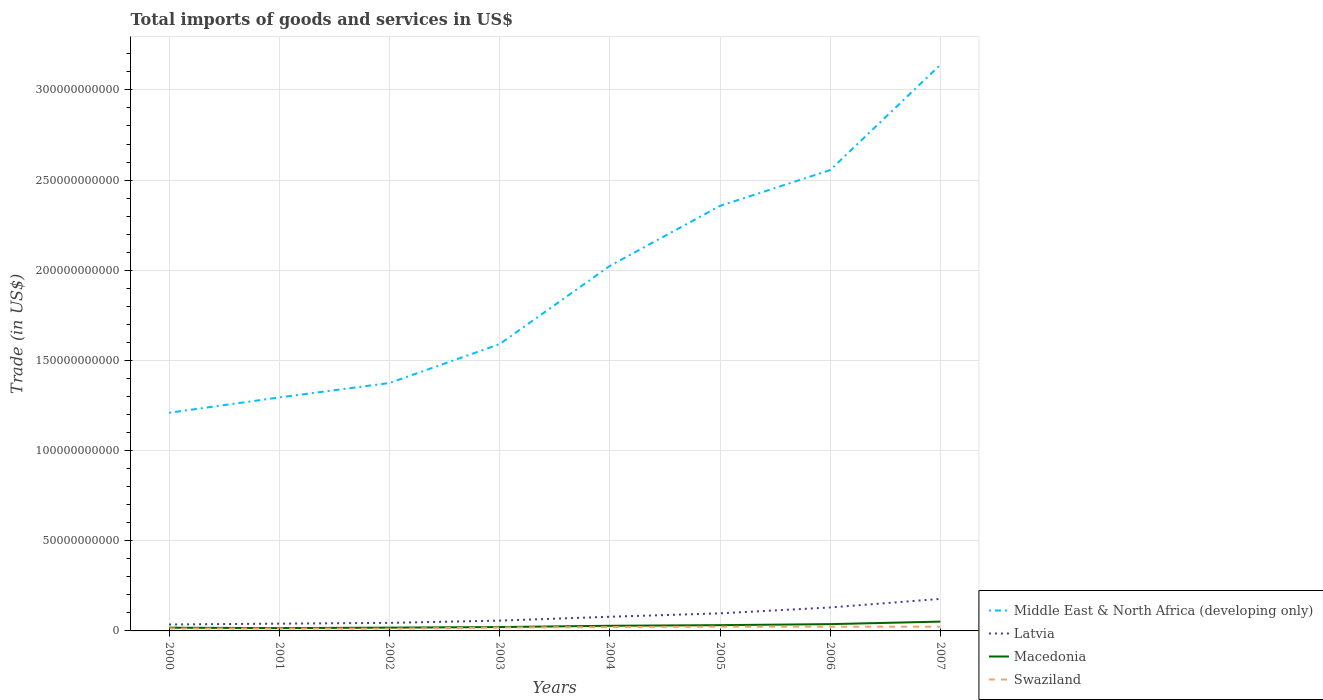How many different coloured lines are there?
Ensure brevity in your answer.  4. Is the number of lines equal to the number of legend labels?
Your response must be concise. Yes. Across all years, what is the maximum total imports of goods and services in Middle East & North Africa (developing only)?
Your response must be concise. 1.21e+11. What is the total total imports of goods and services in Macedonia in the graph?
Your answer should be very brief. -1.38e+09. What is the difference between the highest and the second highest total imports of goods and services in Latvia?
Make the answer very short. 1.42e+1. Are the values on the major ticks of Y-axis written in scientific E-notation?
Give a very brief answer. No. How many legend labels are there?
Your answer should be compact. 4. What is the title of the graph?
Your response must be concise. Total imports of goods and services in US$. What is the label or title of the Y-axis?
Provide a succinct answer. Trade (in US$). What is the Trade (in US$) of Middle East & North Africa (developing only) in 2000?
Provide a short and direct response. 1.21e+11. What is the Trade (in US$) in Latvia in 2000?
Offer a very short reply. 3.56e+09. What is the Trade (in US$) of Macedonia in 2000?
Offer a very short reply. 1.78e+09. What is the Trade (in US$) in Swaziland in 2000?
Make the answer very short. 1.34e+09. What is the Trade (in US$) in Middle East & North Africa (developing only) in 2001?
Provide a succinct answer. 1.29e+11. What is the Trade (in US$) in Latvia in 2001?
Make the answer very short. 4.04e+09. What is the Trade (in US$) of Macedonia in 2001?
Keep it short and to the point. 1.57e+09. What is the Trade (in US$) in Swaziland in 2001?
Your answer should be compact. 1.33e+09. What is the Trade (in US$) of Middle East & North Africa (developing only) in 2002?
Your response must be concise. 1.37e+11. What is the Trade (in US$) in Latvia in 2002?
Your response must be concise. 4.46e+09. What is the Trade (in US$) of Macedonia in 2002?
Give a very brief answer. 1.82e+09. What is the Trade (in US$) of Swaziland in 2002?
Provide a short and direct response. 1.24e+09. What is the Trade (in US$) of Middle East & North Africa (developing only) in 2003?
Ensure brevity in your answer.  1.59e+11. What is the Trade (in US$) in Latvia in 2003?
Offer a terse response. 5.72e+09. What is the Trade (in US$) of Macedonia in 2003?
Ensure brevity in your answer.  2.15e+09. What is the Trade (in US$) in Swaziland in 2003?
Offer a terse response. 1.89e+09. What is the Trade (in US$) of Middle East & North Africa (developing only) in 2004?
Provide a short and direct response. 2.02e+11. What is the Trade (in US$) in Latvia in 2004?
Your answer should be compact. 7.85e+09. What is the Trade (in US$) of Macedonia in 2004?
Keep it short and to the point. 2.85e+09. What is the Trade (in US$) in Swaziland in 2004?
Offer a terse response. 2.12e+09. What is the Trade (in US$) of Middle East & North Africa (developing only) in 2005?
Ensure brevity in your answer.  2.36e+11. What is the Trade (in US$) in Latvia in 2005?
Provide a short and direct response. 9.76e+09. What is the Trade (in US$) in Macedonia in 2005?
Offer a very short reply. 3.19e+09. What is the Trade (in US$) of Swaziland in 2005?
Provide a succinct answer. 2.36e+09. What is the Trade (in US$) in Middle East & North Africa (developing only) in 2006?
Offer a very short reply. 2.56e+11. What is the Trade (in US$) of Latvia in 2006?
Provide a succinct answer. 1.30e+1. What is the Trade (in US$) in Macedonia in 2006?
Provide a succinct answer. 3.76e+09. What is the Trade (in US$) of Swaziland in 2006?
Your response must be concise. 2.33e+09. What is the Trade (in US$) in Middle East & North Africa (developing only) in 2007?
Make the answer very short. 3.14e+11. What is the Trade (in US$) in Latvia in 2007?
Your answer should be compact. 1.78e+1. What is the Trade (in US$) in Macedonia in 2007?
Make the answer very short. 5.17e+09. What is the Trade (in US$) in Swaziland in 2007?
Your answer should be very brief. 2.35e+09. Across all years, what is the maximum Trade (in US$) in Middle East & North Africa (developing only)?
Make the answer very short. 3.14e+11. Across all years, what is the maximum Trade (in US$) of Latvia?
Make the answer very short. 1.78e+1. Across all years, what is the maximum Trade (in US$) in Macedonia?
Offer a very short reply. 5.17e+09. Across all years, what is the maximum Trade (in US$) of Swaziland?
Give a very brief answer. 2.36e+09. Across all years, what is the minimum Trade (in US$) of Middle East & North Africa (developing only)?
Keep it short and to the point. 1.21e+11. Across all years, what is the minimum Trade (in US$) in Latvia?
Provide a succinct answer. 3.56e+09. Across all years, what is the minimum Trade (in US$) of Macedonia?
Ensure brevity in your answer.  1.57e+09. Across all years, what is the minimum Trade (in US$) of Swaziland?
Give a very brief answer. 1.24e+09. What is the total Trade (in US$) in Middle East & North Africa (developing only) in the graph?
Your answer should be very brief. 1.55e+12. What is the total Trade (in US$) in Latvia in the graph?
Give a very brief answer. 6.62e+1. What is the total Trade (in US$) of Macedonia in the graph?
Offer a terse response. 2.23e+1. What is the total Trade (in US$) in Swaziland in the graph?
Give a very brief answer. 1.49e+1. What is the difference between the Trade (in US$) in Middle East & North Africa (developing only) in 2000 and that in 2001?
Offer a very short reply. -8.51e+09. What is the difference between the Trade (in US$) of Latvia in 2000 and that in 2001?
Your answer should be very brief. -4.83e+08. What is the difference between the Trade (in US$) of Macedonia in 2000 and that in 2001?
Give a very brief answer. 2.13e+08. What is the difference between the Trade (in US$) in Swaziland in 2000 and that in 2001?
Your answer should be compact. 1.30e+07. What is the difference between the Trade (in US$) in Middle East & North Africa (developing only) in 2000 and that in 2002?
Provide a succinct answer. -1.65e+1. What is the difference between the Trade (in US$) of Latvia in 2000 and that in 2002?
Ensure brevity in your answer.  -8.98e+08. What is the difference between the Trade (in US$) of Macedonia in 2000 and that in 2002?
Your answer should be very brief. -3.63e+07. What is the difference between the Trade (in US$) of Swaziland in 2000 and that in 2002?
Your response must be concise. 1.05e+08. What is the difference between the Trade (in US$) of Middle East & North Africa (developing only) in 2000 and that in 2003?
Provide a succinct answer. -3.81e+1. What is the difference between the Trade (in US$) in Latvia in 2000 and that in 2003?
Your answer should be compact. -2.16e+09. What is the difference between the Trade (in US$) of Macedonia in 2000 and that in 2003?
Provide a succinct answer. -3.66e+08. What is the difference between the Trade (in US$) in Swaziland in 2000 and that in 2003?
Make the answer very short. -5.47e+08. What is the difference between the Trade (in US$) in Middle East & North Africa (developing only) in 2000 and that in 2004?
Make the answer very short. -8.14e+1. What is the difference between the Trade (in US$) of Latvia in 2000 and that in 2004?
Your response must be concise. -4.29e+09. What is the difference between the Trade (in US$) in Macedonia in 2000 and that in 2004?
Make the answer very short. -1.07e+09. What is the difference between the Trade (in US$) of Swaziland in 2000 and that in 2004?
Keep it short and to the point. -7.76e+08. What is the difference between the Trade (in US$) of Middle East & North Africa (developing only) in 2000 and that in 2005?
Offer a terse response. -1.15e+11. What is the difference between the Trade (in US$) of Latvia in 2000 and that in 2005?
Keep it short and to the point. -6.20e+09. What is the difference between the Trade (in US$) of Macedonia in 2000 and that in 2005?
Offer a very short reply. -1.41e+09. What is the difference between the Trade (in US$) of Swaziland in 2000 and that in 2005?
Keep it short and to the point. -1.01e+09. What is the difference between the Trade (in US$) of Middle East & North Africa (developing only) in 2000 and that in 2006?
Keep it short and to the point. -1.35e+11. What is the difference between the Trade (in US$) in Latvia in 2000 and that in 2006?
Ensure brevity in your answer.  -9.44e+09. What is the difference between the Trade (in US$) of Macedonia in 2000 and that in 2006?
Your response must be concise. -1.98e+09. What is the difference between the Trade (in US$) of Swaziland in 2000 and that in 2006?
Make the answer very short. -9.87e+08. What is the difference between the Trade (in US$) in Middle East & North Africa (developing only) in 2000 and that in 2007?
Ensure brevity in your answer.  -1.93e+11. What is the difference between the Trade (in US$) of Latvia in 2000 and that in 2007?
Keep it short and to the point. -1.42e+1. What is the difference between the Trade (in US$) of Macedonia in 2000 and that in 2007?
Offer a terse response. -3.39e+09. What is the difference between the Trade (in US$) in Swaziland in 2000 and that in 2007?
Provide a succinct answer. -1.01e+09. What is the difference between the Trade (in US$) of Middle East & North Africa (developing only) in 2001 and that in 2002?
Make the answer very short. -7.99e+09. What is the difference between the Trade (in US$) of Latvia in 2001 and that in 2002?
Offer a very short reply. -4.15e+08. What is the difference between the Trade (in US$) of Macedonia in 2001 and that in 2002?
Your answer should be compact. -2.49e+08. What is the difference between the Trade (in US$) of Swaziland in 2001 and that in 2002?
Your answer should be compact. 9.20e+07. What is the difference between the Trade (in US$) in Middle East & North Africa (developing only) in 2001 and that in 2003?
Your answer should be compact. -2.96e+1. What is the difference between the Trade (in US$) in Latvia in 2001 and that in 2003?
Your answer should be compact. -1.67e+09. What is the difference between the Trade (in US$) in Macedonia in 2001 and that in 2003?
Offer a terse response. -5.79e+08. What is the difference between the Trade (in US$) in Swaziland in 2001 and that in 2003?
Make the answer very short. -5.60e+08. What is the difference between the Trade (in US$) of Middle East & North Africa (developing only) in 2001 and that in 2004?
Ensure brevity in your answer.  -7.29e+1. What is the difference between the Trade (in US$) of Latvia in 2001 and that in 2004?
Keep it short and to the point. -3.81e+09. What is the difference between the Trade (in US$) of Macedonia in 2001 and that in 2004?
Make the answer very short. -1.28e+09. What is the difference between the Trade (in US$) of Swaziland in 2001 and that in 2004?
Give a very brief answer. -7.89e+08. What is the difference between the Trade (in US$) in Middle East & North Africa (developing only) in 2001 and that in 2005?
Provide a short and direct response. -1.06e+11. What is the difference between the Trade (in US$) in Latvia in 2001 and that in 2005?
Give a very brief answer. -5.71e+09. What is the difference between the Trade (in US$) of Macedonia in 2001 and that in 2005?
Offer a terse response. -1.63e+09. What is the difference between the Trade (in US$) of Swaziland in 2001 and that in 2005?
Provide a succinct answer. -1.03e+09. What is the difference between the Trade (in US$) of Middle East & North Africa (developing only) in 2001 and that in 2006?
Keep it short and to the point. -1.26e+11. What is the difference between the Trade (in US$) in Latvia in 2001 and that in 2006?
Provide a succinct answer. -8.96e+09. What is the difference between the Trade (in US$) of Macedonia in 2001 and that in 2006?
Keep it short and to the point. -2.19e+09. What is the difference between the Trade (in US$) of Swaziland in 2001 and that in 2006?
Offer a very short reply. -1.00e+09. What is the difference between the Trade (in US$) of Middle East & North Africa (developing only) in 2001 and that in 2007?
Give a very brief answer. -1.84e+11. What is the difference between the Trade (in US$) of Latvia in 2001 and that in 2007?
Give a very brief answer. -1.37e+1. What is the difference between the Trade (in US$) of Macedonia in 2001 and that in 2007?
Ensure brevity in your answer.  -3.60e+09. What is the difference between the Trade (in US$) in Swaziland in 2001 and that in 2007?
Provide a short and direct response. -1.02e+09. What is the difference between the Trade (in US$) in Middle East & North Africa (developing only) in 2002 and that in 2003?
Keep it short and to the point. -2.16e+1. What is the difference between the Trade (in US$) of Latvia in 2002 and that in 2003?
Your answer should be compact. -1.26e+09. What is the difference between the Trade (in US$) of Macedonia in 2002 and that in 2003?
Offer a very short reply. -3.30e+08. What is the difference between the Trade (in US$) of Swaziland in 2002 and that in 2003?
Your answer should be very brief. -6.52e+08. What is the difference between the Trade (in US$) in Middle East & North Africa (developing only) in 2002 and that in 2004?
Your answer should be very brief. -6.49e+1. What is the difference between the Trade (in US$) in Latvia in 2002 and that in 2004?
Provide a short and direct response. -3.39e+09. What is the difference between the Trade (in US$) in Macedonia in 2002 and that in 2004?
Provide a short and direct response. -1.03e+09. What is the difference between the Trade (in US$) of Swaziland in 2002 and that in 2004?
Make the answer very short. -8.80e+08. What is the difference between the Trade (in US$) in Middle East & North Africa (developing only) in 2002 and that in 2005?
Keep it short and to the point. -9.82e+1. What is the difference between the Trade (in US$) of Latvia in 2002 and that in 2005?
Give a very brief answer. -5.30e+09. What is the difference between the Trade (in US$) in Macedonia in 2002 and that in 2005?
Your response must be concise. -1.38e+09. What is the difference between the Trade (in US$) of Swaziland in 2002 and that in 2005?
Ensure brevity in your answer.  -1.12e+09. What is the difference between the Trade (in US$) in Middle East & North Africa (developing only) in 2002 and that in 2006?
Give a very brief answer. -1.18e+11. What is the difference between the Trade (in US$) of Latvia in 2002 and that in 2006?
Provide a succinct answer. -8.55e+09. What is the difference between the Trade (in US$) in Macedonia in 2002 and that in 2006?
Keep it short and to the point. -1.94e+09. What is the difference between the Trade (in US$) in Swaziland in 2002 and that in 2006?
Your answer should be compact. -1.09e+09. What is the difference between the Trade (in US$) in Middle East & North Africa (developing only) in 2002 and that in 2007?
Provide a succinct answer. -1.76e+11. What is the difference between the Trade (in US$) of Latvia in 2002 and that in 2007?
Offer a terse response. -1.33e+1. What is the difference between the Trade (in US$) of Macedonia in 2002 and that in 2007?
Your response must be concise. -3.35e+09. What is the difference between the Trade (in US$) in Swaziland in 2002 and that in 2007?
Your response must be concise. -1.11e+09. What is the difference between the Trade (in US$) of Middle East & North Africa (developing only) in 2003 and that in 2004?
Offer a terse response. -4.34e+1. What is the difference between the Trade (in US$) in Latvia in 2003 and that in 2004?
Your response must be concise. -2.14e+09. What is the difference between the Trade (in US$) in Macedonia in 2003 and that in 2004?
Keep it short and to the point. -7.03e+08. What is the difference between the Trade (in US$) in Swaziland in 2003 and that in 2004?
Give a very brief answer. -2.28e+08. What is the difference between the Trade (in US$) in Middle East & North Africa (developing only) in 2003 and that in 2005?
Make the answer very short. -7.66e+1. What is the difference between the Trade (in US$) of Latvia in 2003 and that in 2005?
Your answer should be very brief. -4.04e+09. What is the difference between the Trade (in US$) of Macedonia in 2003 and that in 2005?
Provide a succinct answer. -1.05e+09. What is the difference between the Trade (in US$) of Swaziland in 2003 and that in 2005?
Your response must be concise. -4.67e+08. What is the difference between the Trade (in US$) of Middle East & North Africa (developing only) in 2003 and that in 2006?
Offer a very short reply. -9.65e+1. What is the difference between the Trade (in US$) of Latvia in 2003 and that in 2006?
Provide a short and direct response. -7.29e+09. What is the difference between the Trade (in US$) in Macedonia in 2003 and that in 2006?
Your answer should be very brief. -1.61e+09. What is the difference between the Trade (in US$) in Swaziland in 2003 and that in 2006?
Make the answer very short. -4.40e+08. What is the difference between the Trade (in US$) of Middle East & North Africa (developing only) in 2003 and that in 2007?
Your response must be concise. -1.55e+11. What is the difference between the Trade (in US$) in Latvia in 2003 and that in 2007?
Your answer should be very brief. -1.20e+1. What is the difference between the Trade (in US$) of Macedonia in 2003 and that in 2007?
Make the answer very short. -3.02e+09. What is the difference between the Trade (in US$) of Swaziland in 2003 and that in 2007?
Provide a succinct answer. -4.61e+08. What is the difference between the Trade (in US$) in Middle East & North Africa (developing only) in 2004 and that in 2005?
Provide a short and direct response. -3.33e+1. What is the difference between the Trade (in US$) in Latvia in 2004 and that in 2005?
Make the answer very short. -1.90e+09. What is the difference between the Trade (in US$) of Macedonia in 2004 and that in 2005?
Keep it short and to the point. -3.43e+08. What is the difference between the Trade (in US$) in Swaziland in 2004 and that in 2005?
Make the answer very short. -2.39e+08. What is the difference between the Trade (in US$) of Middle East & North Africa (developing only) in 2004 and that in 2006?
Your answer should be very brief. -5.31e+1. What is the difference between the Trade (in US$) in Latvia in 2004 and that in 2006?
Keep it short and to the point. -5.15e+09. What is the difference between the Trade (in US$) of Macedonia in 2004 and that in 2006?
Your answer should be very brief. -9.06e+08. What is the difference between the Trade (in US$) of Swaziland in 2004 and that in 2006?
Ensure brevity in your answer.  -2.12e+08. What is the difference between the Trade (in US$) of Middle East & North Africa (developing only) in 2004 and that in 2007?
Give a very brief answer. -1.12e+11. What is the difference between the Trade (in US$) of Latvia in 2004 and that in 2007?
Provide a short and direct response. -9.91e+09. What is the difference between the Trade (in US$) in Macedonia in 2004 and that in 2007?
Provide a short and direct response. -2.32e+09. What is the difference between the Trade (in US$) in Swaziland in 2004 and that in 2007?
Your response must be concise. -2.33e+08. What is the difference between the Trade (in US$) of Middle East & North Africa (developing only) in 2005 and that in 2006?
Keep it short and to the point. -1.99e+1. What is the difference between the Trade (in US$) in Latvia in 2005 and that in 2006?
Your answer should be compact. -3.25e+09. What is the difference between the Trade (in US$) in Macedonia in 2005 and that in 2006?
Your answer should be compact. -5.63e+08. What is the difference between the Trade (in US$) of Swaziland in 2005 and that in 2006?
Your answer should be very brief. 2.73e+07. What is the difference between the Trade (in US$) of Middle East & North Africa (developing only) in 2005 and that in 2007?
Your response must be concise. -7.83e+1. What is the difference between the Trade (in US$) of Latvia in 2005 and that in 2007?
Offer a very short reply. -8.00e+09. What is the difference between the Trade (in US$) of Macedonia in 2005 and that in 2007?
Make the answer very short. -1.97e+09. What is the difference between the Trade (in US$) in Swaziland in 2005 and that in 2007?
Offer a very short reply. 6.24e+06. What is the difference between the Trade (in US$) of Middle East & North Africa (developing only) in 2006 and that in 2007?
Give a very brief answer. -5.84e+1. What is the difference between the Trade (in US$) in Latvia in 2006 and that in 2007?
Your response must be concise. -4.75e+09. What is the difference between the Trade (in US$) of Macedonia in 2006 and that in 2007?
Your answer should be very brief. -1.41e+09. What is the difference between the Trade (in US$) of Swaziland in 2006 and that in 2007?
Offer a very short reply. -2.11e+07. What is the difference between the Trade (in US$) of Middle East & North Africa (developing only) in 2000 and the Trade (in US$) of Latvia in 2001?
Ensure brevity in your answer.  1.17e+11. What is the difference between the Trade (in US$) in Middle East & North Africa (developing only) in 2000 and the Trade (in US$) in Macedonia in 2001?
Your response must be concise. 1.19e+11. What is the difference between the Trade (in US$) in Middle East & North Africa (developing only) in 2000 and the Trade (in US$) in Swaziland in 2001?
Provide a short and direct response. 1.20e+11. What is the difference between the Trade (in US$) of Latvia in 2000 and the Trade (in US$) of Macedonia in 2001?
Provide a succinct answer. 1.99e+09. What is the difference between the Trade (in US$) of Latvia in 2000 and the Trade (in US$) of Swaziland in 2001?
Keep it short and to the point. 2.23e+09. What is the difference between the Trade (in US$) in Macedonia in 2000 and the Trade (in US$) in Swaziland in 2001?
Offer a very short reply. 4.52e+08. What is the difference between the Trade (in US$) of Middle East & North Africa (developing only) in 2000 and the Trade (in US$) of Latvia in 2002?
Give a very brief answer. 1.17e+11. What is the difference between the Trade (in US$) in Middle East & North Africa (developing only) in 2000 and the Trade (in US$) in Macedonia in 2002?
Offer a terse response. 1.19e+11. What is the difference between the Trade (in US$) of Middle East & North Africa (developing only) in 2000 and the Trade (in US$) of Swaziland in 2002?
Your response must be concise. 1.20e+11. What is the difference between the Trade (in US$) in Latvia in 2000 and the Trade (in US$) in Macedonia in 2002?
Keep it short and to the point. 1.74e+09. What is the difference between the Trade (in US$) in Latvia in 2000 and the Trade (in US$) in Swaziland in 2002?
Ensure brevity in your answer.  2.32e+09. What is the difference between the Trade (in US$) of Macedonia in 2000 and the Trade (in US$) of Swaziland in 2002?
Provide a short and direct response. 5.44e+08. What is the difference between the Trade (in US$) in Middle East & North Africa (developing only) in 2000 and the Trade (in US$) in Latvia in 2003?
Your answer should be compact. 1.15e+11. What is the difference between the Trade (in US$) in Middle East & North Africa (developing only) in 2000 and the Trade (in US$) in Macedonia in 2003?
Keep it short and to the point. 1.19e+11. What is the difference between the Trade (in US$) of Middle East & North Africa (developing only) in 2000 and the Trade (in US$) of Swaziland in 2003?
Offer a terse response. 1.19e+11. What is the difference between the Trade (in US$) in Latvia in 2000 and the Trade (in US$) in Macedonia in 2003?
Offer a terse response. 1.41e+09. What is the difference between the Trade (in US$) of Latvia in 2000 and the Trade (in US$) of Swaziland in 2003?
Your answer should be very brief. 1.67e+09. What is the difference between the Trade (in US$) in Macedonia in 2000 and the Trade (in US$) in Swaziland in 2003?
Make the answer very short. -1.08e+08. What is the difference between the Trade (in US$) in Middle East & North Africa (developing only) in 2000 and the Trade (in US$) in Latvia in 2004?
Your answer should be compact. 1.13e+11. What is the difference between the Trade (in US$) of Middle East & North Africa (developing only) in 2000 and the Trade (in US$) of Macedonia in 2004?
Your answer should be compact. 1.18e+11. What is the difference between the Trade (in US$) in Middle East & North Africa (developing only) in 2000 and the Trade (in US$) in Swaziland in 2004?
Keep it short and to the point. 1.19e+11. What is the difference between the Trade (in US$) in Latvia in 2000 and the Trade (in US$) in Macedonia in 2004?
Your answer should be compact. 7.11e+08. What is the difference between the Trade (in US$) of Latvia in 2000 and the Trade (in US$) of Swaziland in 2004?
Offer a terse response. 1.44e+09. What is the difference between the Trade (in US$) of Macedonia in 2000 and the Trade (in US$) of Swaziland in 2004?
Offer a terse response. -3.36e+08. What is the difference between the Trade (in US$) of Middle East & North Africa (developing only) in 2000 and the Trade (in US$) of Latvia in 2005?
Your answer should be compact. 1.11e+11. What is the difference between the Trade (in US$) of Middle East & North Africa (developing only) in 2000 and the Trade (in US$) of Macedonia in 2005?
Your answer should be compact. 1.18e+11. What is the difference between the Trade (in US$) in Middle East & North Africa (developing only) in 2000 and the Trade (in US$) in Swaziland in 2005?
Give a very brief answer. 1.19e+11. What is the difference between the Trade (in US$) in Latvia in 2000 and the Trade (in US$) in Macedonia in 2005?
Ensure brevity in your answer.  3.68e+08. What is the difference between the Trade (in US$) of Latvia in 2000 and the Trade (in US$) of Swaziland in 2005?
Offer a terse response. 1.21e+09. What is the difference between the Trade (in US$) in Macedonia in 2000 and the Trade (in US$) in Swaziland in 2005?
Your answer should be compact. -5.75e+08. What is the difference between the Trade (in US$) of Middle East & North Africa (developing only) in 2000 and the Trade (in US$) of Latvia in 2006?
Provide a short and direct response. 1.08e+11. What is the difference between the Trade (in US$) of Middle East & North Africa (developing only) in 2000 and the Trade (in US$) of Macedonia in 2006?
Offer a terse response. 1.17e+11. What is the difference between the Trade (in US$) of Middle East & North Africa (developing only) in 2000 and the Trade (in US$) of Swaziland in 2006?
Offer a very short reply. 1.19e+11. What is the difference between the Trade (in US$) of Latvia in 2000 and the Trade (in US$) of Macedonia in 2006?
Offer a terse response. -1.96e+08. What is the difference between the Trade (in US$) in Latvia in 2000 and the Trade (in US$) in Swaziland in 2006?
Your answer should be very brief. 1.23e+09. What is the difference between the Trade (in US$) of Macedonia in 2000 and the Trade (in US$) of Swaziland in 2006?
Keep it short and to the point. -5.48e+08. What is the difference between the Trade (in US$) of Middle East & North Africa (developing only) in 2000 and the Trade (in US$) of Latvia in 2007?
Your answer should be compact. 1.03e+11. What is the difference between the Trade (in US$) of Middle East & North Africa (developing only) in 2000 and the Trade (in US$) of Macedonia in 2007?
Your answer should be compact. 1.16e+11. What is the difference between the Trade (in US$) in Middle East & North Africa (developing only) in 2000 and the Trade (in US$) in Swaziland in 2007?
Your response must be concise. 1.19e+11. What is the difference between the Trade (in US$) of Latvia in 2000 and the Trade (in US$) of Macedonia in 2007?
Offer a very short reply. -1.60e+09. What is the difference between the Trade (in US$) of Latvia in 2000 and the Trade (in US$) of Swaziland in 2007?
Your answer should be compact. 1.21e+09. What is the difference between the Trade (in US$) in Macedonia in 2000 and the Trade (in US$) in Swaziland in 2007?
Ensure brevity in your answer.  -5.69e+08. What is the difference between the Trade (in US$) in Middle East & North Africa (developing only) in 2001 and the Trade (in US$) in Latvia in 2002?
Make the answer very short. 1.25e+11. What is the difference between the Trade (in US$) in Middle East & North Africa (developing only) in 2001 and the Trade (in US$) in Macedonia in 2002?
Keep it short and to the point. 1.28e+11. What is the difference between the Trade (in US$) of Middle East & North Africa (developing only) in 2001 and the Trade (in US$) of Swaziland in 2002?
Ensure brevity in your answer.  1.28e+11. What is the difference between the Trade (in US$) of Latvia in 2001 and the Trade (in US$) of Macedonia in 2002?
Give a very brief answer. 2.23e+09. What is the difference between the Trade (in US$) in Latvia in 2001 and the Trade (in US$) in Swaziland in 2002?
Your answer should be compact. 2.81e+09. What is the difference between the Trade (in US$) of Macedonia in 2001 and the Trade (in US$) of Swaziland in 2002?
Provide a succinct answer. 3.32e+08. What is the difference between the Trade (in US$) in Middle East & North Africa (developing only) in 2001 and the Trade (in US$) in Latvia in 2003?
Ensure brevity in your answer.  1.24e+11. What is the difference between the Trade (in US$) in Middle East & North Africa (developing only) in 2001 and the Trade (in US$) in Macedonia in 2003?
Offer a very short reply. 1.27e+11. What is the difference between the Trade (in US$) of Middle East & North Africa (developing only) in 2001 and the Trade (in US$) of Swaziland in 2003?
Provide a succinct answer. 1.28e+11. What is the difference between the Trade (in US$) in Latvia in 2001 and the Trade (in US$) in Macedonia in 2003?
Make the answer very short. 1.90e+09. What is the difference between the Trade (in US$) of Latvia in 2001 and the Trade (in US$) of Swaziland in 2003?
Make the answer very short. 2.16e+09. What is the difference between the Trade (in US$) in Macedonia in 2001 and the Trade (in US$) in Swaziland in 2003?
Provide a short and direct response. -3.21e+08. What is the difference between the Trade (in US$) of Middle East & North Africa (developing only) in 2001 and the Trade (in US$) of Latvia in 2004?
Give a very brief answer. 1.22e+11. What is the difference between the Trade (in US$) of Middle East & North Africa (developing only) in 2001 and the Trade (in US$) of Macedonia in 2004?
Keep it short and to the point. 1.27e+11. What is the difference between the Trade (in US$) in Middle East & North Africa (developing only) in 2001 and the Trade (in US$) in Swaziland in 2004?
Make the answer very short. 1.27e+11. What is the difference between the Trade (in US$) of Latvia in 2001 and the Trade (in US$) of Macedonia in 2004?
Give a very brief answer. 1.19e+09. What is the difference between the Trade (in US$) in Latvia in 2001 and the Trade (in US$) in Swaziland in 2004?
Your response must be concise. 1.93e+09. What is the difference between the Trade (in US$) of Macedonia in 2001 and the Trade (in US$) of Swaziland in 2004?
Your answer should be very brief. -5.49e+08. What is the difference between the Trade (in US$) of Middle East & North Africa (developing only) in 2001 and the Trade (in US$) of Latvia in 2005?
Your answer should be very brief. 1.20e+11. What is the difference between the Trade (in US$) of Middle East & North Africa (developing only) in 2001 and the Trade (in US$) of Macedonia in 2005?
Your answer should be very brief. 1.26e+11. What is the difference between the Trade (in US$) in Middle East & North Africa (developing only) in 2001 and the Trade (in US$) in Swaziland in 2005?
Ensure brevity in your answer.  1.27e+11. What is the difference between the Trade (in US$) of Latvia in 2001 and the Trade (in US$) of Macedonia in 2005?
Offer a terse response. 8.51e+08. What is the difference between the Trade (in US$) of Latvia in 2001 and the Trade (in US$) of Swaziland in 2005?
Ensure brevity in your answer.  1.69e+09. What is the difference between the Trade (in US$) of Macedonia in 2001 and the Trade (in US$) of Swaziland in 2005?
Offer a very short reply. -7.88e+08. What is the difference between the Trade (in US$) in Middle East & North Africa (developing only) in 2001 and the Trade (in US$) in Latvia in 2006?
Your answer should be very brief. 1.16e+11. What is the difference between the Trade (in US$) of Middle East & North Africa (developing only) in 2001 and the Trade (in US$) of Macedonia in 2006?
Provide a short and direct response. 1.26e+11. What is the difference between the Trade (in US$) in Middle East & North Africa (developing only) in 2001 and the Trade (in US$) in Swaziland in 2006?
Your answer should be very brief. 1.27e+11. What is the difference between the Trade (in US$) of Latvia in 2001 and the Trade (in US$) of Macedonia in 2006?
Ensure brevity in your answer.  2.87e+08. What is the difference between the Trade (in US$) of Latvia in 2001 and the Trade (in US$) of Swaziland in 2006?
Make the answer very short. 1.72e+09. What is the difference between the Trade (in US$) of Macedonia in 2001 and the Trade (in US$) of Swaziland in 2006?
Your answer should be compact. -7.61e+08. What is the difference between the Trade (in US$) in Middle East & North Africa (developing only) in 2001 and the Trade (in US$) in Latvia in 2007?
Make the answer very short. 1.12e+11. What is the difference between the Trade (in US$) of Middle East & North Africa (developing only) in 2001 and the Trade (in US$) of Macedonia in 2007?
Provide a succinct answer. 1.24e+11. What is the difference between the Trade (in US$) of Middle East & North Africa (developing only) in 2001 and the Trade (in US$) of Swaziland in 2007?
Keep it short and to the point. 1.27e+11. What is the difference between the Trade (in US$) of Latvia in 2001 and the Trade (in US$) of Macedonia in 2007?
Your answer should be very brief. -1.12e+09. What is the difference between the Trade (in US$) in Latvia in 2001 and the Trade (in US$) in Swaziland in 2007?
Your answer should be very brief. 1.69e+09. What is the difference between the Trade (in US$) in Macedonia in 2001 and the Trade (in US$) in Swaziland in 2007?
Provide a succinct answer. -7.82e+08. What is the difference between the Trade (in US$) in Middle East & North Africa (developing only) in 2002 and the Trade (in US$) in Latvia in 2003?
Offer a terse response. 1.32e+11. What is the difference between the Trade (in US$) of Middle East & North Africa (developing only) in 2002 and the Trade (in US$) of Macedonia in 2003?
Provide a succinct answer. 1.35e+11. What is the difference between the Trade (in US$) in Middle East & North Africa (developing only) in 2002 and the Trade (in US$) in Swaziland in 2003?
Your response must be concise. 1.36e+11. What is the difference between the Trade (in US$) of Latvia in 2002 and the Trade (in US$) of Macedonia in 2003?
Keep it short and to the point. 2.31e+09. What is the difference between the Trade (in US$) in Latvia in 2002 and the Trade (in US$) in Swaziland in 2003?
Provide a succinct answer. 2.57e+09. What is the difference between the Trade (in US$) in Macedonia in 2002 and the Trade (in US$) in Swaziland in 2003?
Provide a succinct answer. -7.17e+07. What is the difference between the Trade (in US$) in Middle East & North Africa (developing only) in 2002 and the Trade (in US$) in Latvia in 2004?
Your answer should be compact. 1.30e+11. What is the difference between the Trade (in US$) in Middle East & North Africa (developing only) in 2002 and the Trade (in US$) in Macedonia in 2004?
Keep it short and to the point. 1.35e+11. What is the difference between the Trade (in US$) of Middle East & North Africa (developing only) in 2002 and the Trade (in US$) of Swaziland in 2004?
Make the answer very short. 1.35e+11. What is the difference between the Trade (in US$) of Latvia in 2002 and the Trade (in US$) of Macedonia in 2004?
Offer a terse response. 1.61e+09. What is the difference between the Trade (in US$) of Latvia in 2002 and the Trade (in US$) of Swaziland in 2004?
Your answer should be very brief. 2.34e+09. What is the difference between the Trade (in US$) in Macedonia in 2002 and the Trade (in US$) in Swaziland in 2004?
Provide a succinct answer. -3.00e+08. What is the difference between the Trade (in US$) of Middle East & North Africa (developing only) in 2002 and the Trade (in US$) of Latvia in 2005?
Your answer should be very brief. 1.28e+11. What is the difference between the Trade (in US$) in Middle East & North Africa (developing only) in 2002 and the Trade (in US$) in Macedonia in 2005?
Ensure brevity in your answer.  1.34e+11. What is the difference between the Trade (in US$) in Middle East & North Africa (developing only) in 2002 and the Trade (in US$) in Swaziland in 2005?
Your answer should be compact. 1.35e+11. What is the difference between the Trade (in US$) in Latvia in 2002 and the Trade (in US$) in Macedonia in 2005?
Your answer should be very brief. 1.27e+09. What is the difference between the Trade (in US$) in Latvia in 2002 and the Trade (in US$) in Swaziland in 2005?
Offer a terse response. 2.10e+09. What is the difference between the Trade (in US$) in Macedonia in 2002 and the Trade (in US$) in Swaziland in 2005?
Provide a succinct answer. -5.39e+08. What is the difference between the Trade (in US$) of Middle East & North Africa (developing only) in 2002 and the Trade (in US$) of Latvia in 2006?
Offer a terse response. 1.24e+11. What is the difference between the Trade (in US$) in Middle East & North Africa (developing only) in 2002 and the Trade (in US$) in Macedonia in 2006?
Offer a very short reply. 1.34e+11. What is the difference between the Trade (in US$) of Middle East & North Africa (developing only) in 2002 and the Trade (in US$) of Swaziland in 2006?
Provide a short and direct response. 1.35e+11. What is the difference between the Trade (in US$) of Latvia in 2002 and the Trade (in US$) of Macedonia in 2006?
Offer a terse response. 7.03e+08. What is the difference between the Trade (in US$) of Latvia in 2002 and the Trade (in US$) of Swaziland in 2006?
Provide a short and direct response. 2.13e+09. What is the difference between the Trade (in US$) in Macedonia in 2002 and the Trade (in US$) in Swaziland in 2006?
Make the answer very short. -5.12e+08. What is the difference between the Trade (in US$) of Middle East & North Africa (developing only) in 2002 and the Trade (in US$) of Latvia in 2007?
Provide a succinct answer. 1.20e+11. What is the difference between the Trade (in US$) in Middle East & North Africa (developing only) in 2002 and the Trade (in US$) in Macedonia in 2007?
Your response must be concise. 1.32e+11. What is the difference between the Trade (in US$) in Middle East & North Africa (developing only) in 2002 and the Trade (in US$) in Swaziland in 2007?
Give a very brief answer. 1.35e+11. What is the difference between the Trade (in US$) in Latvia in 2002 and the Trade (in US$) in Macedonia in 2007?
Make the answer very short. -7.07e+08. What is the difference between the Trade (in US$) in Latvia in 2002 and the Trade (in US$) in Swaziland in 2007?
Provide a short and direct response. 2.11e+09. What is the difference between the Trade (in US$) of Macedonia in 2002 and the Trade (in US$) of Swaziland in 2007?
Make the answer very short. -5.33e+08. What is the difference between the Trade (in US$) in Middle East & North Africa (developing only) in 2003 and the Trade (in US$) in Latvia in 2004?
Your answer should be compact. 1.51e+11. What is the difference between the Trade (in US$) in Middle East & North Africa (developing only) in 2003 and the Trade (in US$) in Macedonia in 2004?
Offer a terse response. 1.56e+11. What is the difference between the Trade (in US$) of Middle East & North Africa (developing only) in 2003 and the Trade (in US$) of Swaziland in 2004?
Provide a succinct answer. 1.57e+11. What is the difference between the Trade (in US$) of Latvia in 2003 and the Trade (in US$) of Macedonia in 2004?
Your answer should be very brief. 2.87e+09. What is the difference between the Trade (in US$) of Latvia in 2003 and the Trade (in US$) of Swaziland in 2004?
Your answer should be very brief. 3.60e+09. What is the difference between the Trade (in US$) of Macedonia in 2003 and the Trade (in US$) of Swaziland in 2004?
Your response must be concise. 3.00e+07. What is the difference between the Trade (in US$) in Middle East & North Africa (developing only) in 2003 and the Trade (in US$) in Latvia in 2005?
Your answer should be compact. 1.49e+11. What is the difference between the Trade (in US$) in Middle East & North Africa (developing only) in 2003 and the Trade (in US$) in Macedonia in 2005?
Keep it short and to the point. 1.56e+11. What is the difference between the Trade (in US$) in Middle East & North Africa (developing only) in 2003 and the Trade (in US$) in Swaziland in 2005?
Ensure brevity in your answer.  1.57e+11. What is the difference between the Trade (in US$) in Latvia in 2003 and the Trade (in US$) in Macedonia in 2005?
Offer a terse response. 2.52e+09. What is the difference between the Trade (in US$) in Latvia in 2003 and the Trade (in US$) in Swaziland in 2005?
Give a very brief answer. 3.36e+09. What is the difference between the Trade (in US$) in Macedonia in 2003 and the Trade (in US$) in Swaziland in 2005?
Your answer should be compact. -2.09e+08. What is the difference between the Trade (in US$) of Middle East & North Africa (developing only) in 2003 and the Trade (in US$) of Latvia in 2006?
Your response must be concise. 1.46e+11. What is the difference between the Trade (in US$) in Middle East & North Africa (developing only) in 2003 and the Trade (in US$) in Macedonia in 2006?
Your answer should be very brief. 1.55e+11. What is the difference between the Trade (in US$) in Middle East & North Africa (developing only) in 2003 and the Trade (in US$) in Swaziland in 2006?
Make the answer very short. 1.57e+11. What is the difference between the Trade (in US$) of Latvia in 2003 and the Trade (in US$) of Macedonia in 2006?
Give a very brief answer. 1.96e+09. What is the difference between the Trade (in US$) of Latvia in 2003 and the Trade (in US$) of Swaziland in 2006?
Provide a short and direct response. 3.39e+09. What is the difference between the Trade (in US$) in Macedonia in 2003 and the Trade (in US$) in Swaziland in 2006?
Your answer should be compact. -1.82e+08. What is the difference between the Trade (in US$) in Middle East & North Africa (developing only) in 2003 and the Trade (in US$) in Latvia in 2007?
Keep it short and to the point. 1.41e+11. What is the difference between the Trade (in US$) in Middle East & North Africa (developing only) in 2003 and the Trade (in US$) in Macedonia in 2007?
Provide a short and direct response. 1.54e+11. What is the difference between the Trade (in US$) in Middle East & North Africa (developing only) in 2003 and the Trade (in US$) in Swaziland in 2007?
Ensure brevity in your answer.  1.57e+11. What is the difference between the Trade (in US$) of Latvia in 2003 and the Trade (in US$) of Macedonia in 2007?
Offer a terse response. 5.50e+08. What is the difference between the Trade (in US$) of Latvia in 2003 and the Trade (in US$) of Swaziland in 2007?
Provide a succinct answer. 3.37e+09. What is the difference between the Trade (in US$) in Macedonia in 2003 and the Trade (in US$) in Swaziland in 2007?
Offer a terse response. -2.03e+08. What is the difference between the Trade (in US$) of Middle East & North Africa (developing only) in 2004 and the Trade (in US$) of Latvia in 2005?
Your answer should be compact. 1.93e+11. What is the difference between the Trade (in US$) of Middle East & North Africa (developing only) in 2004 and the Trade (in US$) of Macedonia in 2005?
Keep it short and to the point. 1.99e+11. What is the difference between the Trade (in US$) of Middle East & North Africa (developing only) in 2004 and the Trade (in US$) of Swaziland in 2005?
Give a very brief answer. 2.00e+11. What is the difference between the Trade (in US$) of Latvia in 2004 and the Trade (in US$) of Macedonia in 2005?
Make the answer very short. 4.66e+09. What is the difference between the Trade (in US$) of Latvia in 2004 and the Trade (in US$) of Swaziland in 2005?
Provide a succinct answer. 5.50e+09. What is the difference between the Trade (in US$) in Macedonia in 2004 and the Trade (in US$) in Swaziland in 2005?
Give a very brief answer. 4.94e+08. What is the difference between the Trade (in US$) in Middle East & North Africa (developing only) in 2004 and the Trade (in US$) in Latvia in 2006?
Keep it short and to the point. 1.89e+11. What is the difference between the Trade (in US$) of Middle East & North Africa (developing only) in 2004 and the Trade (in US$) of Macedonia in 2006?
Keep it short and to the point. 1.99e+11. What is the difference between the Trade (in US$) of Middle East & North Africa (developing only) in 2004 and the Trade (in US$) of Swaziland in 2006?
Keep it short and to the point. 2.00e+11. What is the difference between the Trade (in US$) of Latvia in 2004 and the Trade (in US$) of Macedonia in 2006?
Keep it short and to the point. 4.10e+09. What is the difference between the Trade (in US$) in Latvia in 2004 and the Trade (in US$) in Swaziland in 2006?
Keep it short and to the point. 5.52e+09. What is the difference between the Trade (in US$) of Macedonia in 2004 and the Trade (in US$) of Swaziland in 2006?
Give a very brief answer. 5.22e+08. What is the difference between the Trade (in US$) of Middle East & North Africa (developing only) in 2004 and the Trade (in US$) of Latvia in 2007?
Give a very brief answer. 1.85e+11. What is the difference between the Trade (in US$) of Middle East & North Africa (developing only) in 2004 and the Trade (in US$) of Macedonia in 2007?
Provide a short and direct response. 1.97e+11. What is the difference between the Trade (in US$) in Middle East & North Africa (developing only) in 2004 and the Trade (in US$) in Swaziland in 2007?
Provide a short and direct response. 2.00e+11. What is the difference between the Trade (in US$) in Latvia in 2004 and the Trade (in US$) in Macedonia in 2007?
Make the answer very short. 2.69e+09. What is the difference between the Trade (in US$) in Latvia in 2004 and the Trade (in US$) in Swaziland in 2007?
Offer a very short reply. 5.50e+09. What is the difference between the Trade (in US$) in Macedonia in 2004 and the Trade (in US$) in Swaziland in 2007?
Ensure brevity in your answer.  5.01e+08. What is the difference between the Trade (in US$) in Middle East & North Africa (developing only) in 2005 and the Trade (in US$) in Latvia in 2006?
Your answer should be very brief. 2.23e+11. What is the difference between the Trade (in US$) of Middle East & North Africa (developing only) in 2005 and the Trade (in US$) of Macedonia in 2006?
Keep it short and to the point. 2.32e+11. What is the difference between the Trade (in US$) of Middle East & North Africa (developing only) in 2005 and the Trade (in US$) of Swaziland in 2006?
Offer a very short reply. 2.33e+11. What is the difference between the Trade (in US$) of Latvia in 2005 and the Trade (in US$) of Macedonia in 2006?
Ensure brevity in your answer.  6.00e+09. What is the difference between the Trade (in US$) of Latvia in 2005 and the Trade (in US$) of Swaziland in 2006?
Your answer should be very brief. 7.43e+09. What is the difference between the Trade (in US$) in Macedonia in 2005 and the Trade (in US$) in Swaziland in 2006?
Your response must be concise. 8.65e+08. What is the difference between the Trade (in US$) in Middle East & North Africa (developing only) in 2005 and the Trade (in US$) in Latvia in 2007?
Offer a very short reply. 2.18e+11. What is the difference between the Trade (in US$) of Middle East & North Africa (developing only) in 2005 and the Trade (in US$) of Macedonia in 2007?
Your response must be concise. 2.31e+11. What is the difference between the Trade (in US$) of Middle East & North Africa (developing only) in 2005 and the Trade (in US$) of Swaziland in 2007?
Offer a very short reply. 2.33e+11. What is the difference between the Trade (in US$) in Latvia in 2005 and the Trade (in US$) in Macedonia in 2007?
Provide a short and direct response. 4.59e+09. What is the difference between the Trade (in US$) of Latvia in 2005 and the Trade (in US$) of Swaziland in 2007?
Offer a terse response. 7.41e+09. What is the difference between the Trade (in US$) of Macedonia in 2005 and the Trade (in US$) of Swaziland in 2007?
Provide a short and direct response. 8.44e+08. What is the difference between the Trade (in US$) in Middle East & North Africa (developing only) in 2006 and the Trade (in US$) in Latvia in 2007?
Your response must be concise. 2.38e+11. What is the difference between the Trade (in US$) of Middle East & North Africa (developing only) in 2006 and the Trade (in US$) of Macedonia in 2007?
Keep it short and to the point. 2.50e+11. What is the difference between the Trade (in US$) in Middle East & North Africa (developing only) in 2006 and the Trade (in US$) in Swaziland in 2007?
Keep it short and to the point. 2.53e+11. What is the difference between the Trade (in US$) in Latvia in 2006 and the Trade (in US$) in Macedonia in 2007?
Provide a short and direct response. 7.84e+09. What is the difference between the Trade (in US$) of Latvia in 2006 and the Trade (in US$) of Swaziland in 2007?
Make the answer very short. 1.07e+1. What is the difference between the Trade (in US$) in Macedonia in 2006 and the Trade (in US$) in Swaziland in 2007?
Make the answer very short. 1.41e+09. What is the average Trade (in US$) in Middle East & North Africa (developing only) per year?
Your answer should be compact. 1.94e+11. What is the average Trade (in US$) of Latvia per year?
Provide a short and direct response. 8.27e+09. What is the average Trade (in US$) of Macedonia per year?
Your answer should be compact. 2.79e+09. What is the average Trade (in US$) in Swaziland per year?
Keep it short and to the point. 1.87e+09. In the year 2000, what is the difference between the Trade (in US$) of Middle East & North Africa (developing only) and Trade (in US$) of Latvia?
Offer a terse response. 1.17e+11. In the year 2000, what is the difference between the Trade (in US$) in Middle East & North Africa (developing only) and Trade (in US$) in Macedonia?
Your answer should be very brief. 1.19e+11. In the year 2000, what is the difference between the Trade (in US$) in Middle East & North Africa (developing only) and Trade (in US$) in Swaziland?
Make the answer very short. 1.20e+11. In the year 2000, what is the difference between the Trade (in US$) in Latvia and Trade (in US$) in Macedonia?
Provide a succinct answer. 1.78e+09. In the year 2000, what is the difference between the Trade (in US$) of Latvia and Trade (in US$) of Swaziland?
Offer a very short reply. 2.22e+09. In the year 2000, what is the difference between the Trade (in US$) in Macedonia and Trade (in US$) in Swaziland?
Offer a terse response. 4.40e+08. In the year 2001, what is the difference between the Trade (in US$) of Middle East & North Africa (developing only) and Trade (in US$) of Latvia?
Ensure brevity in your answer.  1.25e+11. In the year 2001, what is the difference between the Trade (in US$) of Middle East & North Africa (developing only) and Trade (in US$) of Macedonia?
Offer a terse response. 1.28e+11. In the year 2001, what is the difference between the Trade (in US$) in Middle East & North Africa (developing only) and Trade (in US$) in Swaziland?
Offer a very short reply. 1.28e+11. In the year 2001, what is the difference between the Trade (in US$) of Latvia and Trade (in US$) of Macedonia?
Ensure brevity in your answer.  2.48e+09. In the year 2001, what is the difference between the Trade (in US$) of Latvia and Trade (in US$) of Swaziland?
Your response must be concise. 2.72e+09. In the year 2001, what is the difference between the Trade (in US$) of Macedonia and Trade (in US$) of Swaziland?
Ensure brevity in your answer.  2.40e+08. In the year 2002, what is the difference between the Trade (in US$) in Middle East & North Africa (developing only) and Trade (in US$) in Latvia?
Provide a succinct answer. 1.33e+11. In the year 2002, what is the difference between the Trade (in US$) in Middle East & North Africa (developing only) and Trade (in US$) in Macedonia?
Offer a very short reply. 1.36e+11. In the year 2002, what is the difference between the Trade (in US$) of Middle East & North Africa (developing only) and Trade (in US$) of Swaziland?
Keep it short and to the point. 1.36e+11. In the year 2002, what is the difference between the Trade (in US$) of Latvia and Trade (in US$) of Macedonia?
Make the answer very short. 2.64e+09. In the year 2002, what is the difference between the Trade (in US$) in Latvia and Trade (in US$) in Swaziland?
Offer a very short reply. 3.22e+09. In the year 2002, what is the difference between the Trade (in US$) in Macedonia and Trade (in US$) in Swaziland?
Provide a short and direct response. 5.81e+08. In the year 2003, what is the difference between the Trade (in US$) of Middle East & North Africa (developing only) and Trade (in US$) of Latvia?
Ensure brevity in your answer.  1.53e+11. In the year 2003, what is the difference between the Trade (in US$) in Middle East & North Africa (developing only) and Trade (in US$) in Macedonia?
Provide a short and direct response. 1.57e+11. In the year 2003, what is the difference between the Trade (in US$) in Middle East & North Africa (developing only) and Trade (in US$) in Swaziland?
Ensure brevity in your answer.  1.57e+11. In the year 2003, what is the difference between the Trade (in US$) in Latvia and Trade (in US$) in Macedonia?
Your response must be concise. 3.57e+09. In the year 2003, what is the difference between the Trade (in US$) in Latvia and Trade (in US$) in Swaziland?
Provide a succinct answer. 3.83e+09. In the year 2003, what is the difference between the Trade (in US$) of Macedonia and Trade (in US$) of Swaziland?
Offer a terse response. 2.58e+08. In the year 2004, what is the difference between the Trade (in US$) of Middle East & North Africa (developing only) and Trade (in US$) of Latvia?
Provide a short and direct response. 1.95e+11. In the year 2004, what is the difference between the Trade (in US$) in Middle East & North Africa (developing only) and Trade (in US$) in Macedonia?
Offer a very short reply. 2.00e+11. In the year 2004, what is the difference between the Trade (in US$) in Middle East & North Africa (developing only) and Trade (in US$) in Swaziland?
Ensure brevity in your answer.  2.00e+11. In the year 2004, what is the difference between the Trade (in US$) in Latvia and Trade (in US$) in Macedonia?
Provide a short and direct response. 5.00e+09. In the year 2004, what is the difference between the Trade (in US$) of Latvia and Trade (in US$) of Swaziland?
Your answer should be compact. 5.74e+09. In the year 2004, what is the difference between the Trade (in US$) of Macedonia and Trade (in US$) of Swaziland?
Your answer should be very brief. 7.33e+08. In the year 2005, what is the difference between the Trade (in US$) of Middle East & North Africa (developing only) and Trade (in US$) of Latvia?
Provide a succinct answer. 2.26e+11. In the year 2005, what is the difference between the Trade (in US$) in Middle East & North Africa (developing only) and Trade (in US$) in Macedonia?
Provide a succinct answer. 2.32e+11. In the year 2005, what is the difference between the Trade (in US$) in Middle East & North Africa (developing only) and Trade (in US$) in Swaziland?
Your answer should be very brief. 2.33e+11. In the year 2005, what is the difference between the Trade (in US$) in Latvia and Trade (in US$) in Macedonia?
Ensure brevity in your answer.  6.56e+09. In the year 2005, what is the difference between the Trade (in US$) of Latvia and Trade (in US$) of Swaziland?
Give a very brief answer. 7.40e+09. In the year 2005, what is the difference between the Trade (in US$) of Macedonia and Trade (in US$) of Swaziland?
Provide a short and direct response. 8.38e+08. In the year 2006, what is the difference between the Trade (in US$) in Middle East & North Africa (developing only) and Trade (in US$) in Latvia?
Keep it short and to the point. 2.43e+11. In the year 2006, what is the difference between the Trade (in US$) in Middle East & North Africa (developing only) and Trade (in US$) in Macedonia?
Offer a terse response. 2.52e+11. In the year 2006, what is the difference between the Trade (in US$) in Middle East & North Africa (developing only) and Trade (in US$) in Swaziland?
Your answer should be compact. 2.53e+11. In the year 2006, what is the difference between the Trade (in US$) in Latvia and Trade (in US$) in Macedonia?
Ensure brevity in your answer.  9.25e+09. In the year 2006, what is the difference between the Trade (in US$) of Latvia and Trade (in US$) of Swaziland?
Your answer should be compact. 1.07e+1. In the year 2006, what is the difference between the Trade (in US$) in Macedonia and Trade (in US$) in Swaziland?
Make the answer very short. 1.43e+09. In the year 2007, what is the difference between the Trade (in US$) of Middle East & North Africa (developing only) and Trade (in US$) of Latvia?
Your response must be concise. 2.96e+11. In the year 2007, what is the difference between the Trade (in US$) in Middle East & North Africa (developing only) and Trade (in US$) in Macedonia?
Offer a very short reply. 3.09e+11. In the year 2007, what is the difference between the Trade (in US$) of Middle East & North Africa (developing only) and Trade (in US$) of Swaziland?
Make the answer very short. 3.12e+11. In the year 2007, what is the difference between the Trade (in US$) in Latvia and Trade (in US$) in Macedonia?
Provide a succinct answer. 1.26e+1. In the year 2007, what is the difference between the Trade (in US$) of Latvia and Trade (in US$) of Swaziland?
Offer a very short reply. 1.54e+1. In the year 2007, what is the difference between the Trade (in US$) of Macedonia and Trade (in US$) of Swaziland?
Your response must be concise. 2.82e+09. What is the ratio of the Trade (in US$) of Middle East & North Africa (developing only) in 2000 to that in 2001?
Your response must be concise. 0.93. What is the ratio of the Trade (in US$) in Latvia in 2000 to that in 2001?
Make the answer very short. 0.88. What is the ratio of the Trade (in US$) of Macedonia in 2000 to that in 2001?
Provide a short and direct response. 1.14. What is the ratio of the Trade (in US$) of Swaziland in 2000 to that in 2001?
Your response must be concise. 1.01. What is the ratio of the Trade (in US$) of Middle East & North Africa (developing only) in 2000 to that in 2002?
Ensure brevity in your answer.  0.88. What is the ratio of the Trade (in US$) of Latvia in 2000 to that in 2002?
Provide a short and direct response. 0.8. What is the ratio of the Trade (in US$) of Swaziland in 2000 to that in 2002?
Your response must be concise. 1.08. What is the ratio of the Trade (in US$) of Middle East & North Africa (developing only) in 2000 to that in 2003?
Offer a terse response. 0.76. What is the ratio of the Trade (in US$) in Latvia in 2000 to that in 2003?
Offer a very short reply. 0.62. What is the ratio of the Trade (in US$) in Macedonia in 2000 to that in 2003?
Keep it short and to the point. 0.83. What is the ratio of the Trade (in US$) in Swaziland in 2000 to that in 2003?
Your response must be concise. 0.71. What is the ratio of the Trade (in US$) of Middle East & North Africa (developing only) in 2000 to that in 2004?
Your answer should be compact. 0.6. What is the ratio of the Trade (in US$) of Latvia in 2000 to that in 2004?
Your response must be concise. 0.45. What is the ratio of the Trade (in US$) of Macedonia in 2000 to that in 2004?
Provide a short and direct response. 0.62. What is the ratio of the Trade (in US$) of Swaziland in 2000 to that in 2004?
Keep it short and to the point. 0.63. What is the ratio of the Trade (in US$) of Middle East & North Africa (developing only) in 2000 to that in 2005?
Ensure brevity in your answer.  0.51. What is the ratio of the Trade (in US$) in Latvia in 2000 to that in 2005?
Your response must be concise. 0.36. What is the ratio of the Trade (in US$) of Macedonia in 2000 to that in 2005?
Your response must be concise. 0.56. What is the ratio of the Trade (in US$) of Swaziland in 2000 to that in 2005?
Make the answer very short. 0.57. What is the ratio of the Trade (in US$) in Middle East & North Africa (developing only) in 2000 to that in 2006?
Keep it short and to the point. 0.47. What is the ratio of the Trade (in US$) in Latvia in 2000 to that in 2006?
Provide a succinct answer. 0.27. What is the ratio of the Trade (in US$) of Macedonia in 2000 to that in 2006?
Keep it short and to the point. 0.47. What is the ratio of the Trade (in US$) of Swaziland in 2000 to that in 2006?
Ensure brevity in your answer.  0.58. What is the ratio of the Trade (in US$) in Middle East & North Africa (developing only) in 2000 to that in 2007?
Provide a succinct answer. 0.39. What is the ratio of the Trade (in US$) in Latvia in 2000 to that in 2007?
Provide a succinct answer. 0.2. What is the ratio of the Trade (in US$) in Macedonia in 2000 to that in 2007?
Provide a succinct answer. 0.34. What is the ratio of the Trade (in US$) in Swaziland in 2000 to that in 2007?
Provide a short and direct response. 0.57. What is the ratio of the Trade (in US$) of Middle East & North Africa (developing only) in 2001 to that in 2002?
Your response must be concise. 0.94. What is the ratio of the Trade (in US$) of Latvia in 2001 to that in 2002?
Your answer should be very brief. 0.91. What is the ratio of the Trade (in US$) in Macedonia in 2001 to that in 2002?
Ensure brevity in your answer.  0.86. What is the ratio of the Trade (in US$) in Swaziland in 2001 to that in 2002?
Your response must be concise. 1.07. What is the ratio of the Trade (in US$) of Middle East & North Africa (developing only) in 2001 to that in 2003?
Make the answer very short. 0.81. What is the ratio of the Trade (in US$) in Latvia in 2001 to that in 2003?
Your response must be concise. 0.71. What is the ratio of the Trade (in US$) in Macedonia in 2001 to that in 2003?
Your response must be concise. 0.73. What is the ratio of the Trade (in US$) of Swaziland in 2001 to that in 2003?
Provide a short and direct response. 0.7. What is the ratio of the Trade (in US$) of Middle East & North Africa (developing only) in 2001 to that in 2004?
Give a very brief answer. 0.64. What is the ratio of the Trade (in US$) in Latvia in 2001 to that in 2004?
Offer a very short reply. 0.52. What is the ratio of the Trade (in US$) of Macedonia in 2001 to that in 2004?
Provide a succinct answer. 0.55. What is the ratio of the Trade (in US$) of Swaziland in 2001 to that in 2004?
Provide a short and direct response. 0.63. What is the ratio of the Trade (in US$) of Middle East & North Africa (developing only) in 2001 to that in 2005?
Offer a very short reply. 0.55. What is the ratio of the Trade (in US$) in Latvia in 2001 to that in 2005?
Keep it short and to the point. 0.41. What is the ratio of the Trade (in US$) in Macedonia in 2001 to that in 2005?
Your response must be concise. 0.49. What is the ratio of the Trade (in US$) of Swaziland in 2001 to that in 2005?
Provide a succinct answer. 0.56. What is the ratio of the Trade (in US$) in Middle East & North Africa (developing only) in 2001 to that in 2006?
Your answer should be compact. 0.51. What is the ratio of the Trade (in US$) in Latvia in 2001 to that in 2006?
Provide a succinct answer. 0.31. What is the ratio of the Trade (in US$) of Macedonia in 2001 to that in 2006?
Give a very brief answer. 0.42. What is the ratio of the Trade (in US$) in Swaziland in 2001 to that in 2006?
Make the answer very short. 0.57. What is the ratio of the Trade (in US$) of Middle East & North Africa (developing only) in 2001 to that in 2007?
Offer a very short reply. 0.41. What is the ratio of the Trade (in US$) of Latvia in 2001 to that in 2007?
Your response must be concise. 0.23. What is the ratio of the Trade (in US$) of Macedonia in 2001 to that in 2007?
Provide a short and direct response. 0.3. What is the ratio of the Trade (in US$) in Swaziland in 2001 to that in 2007?
Ensure brevity in your answer.  0.57. What is the ratio of the Trade (in US$) of Middle East & North Africa (developing only) in 2002 to that in 2003?
Give a very brief answer. 0.86. What is the ratio of the Trade (in US$) in Latvia in 2002 to that in 2003?
Provide a short and direct response. 0.78. What is the ratio of the Trade (in US$) of Macedonia in 2002 to that in 2003?
Offer a terse response. 0.85. What is the ratio of the Trade (in US$) of Swaziland in 2002 to that in 2003?
Keep it short and to the point. 0.65. What is the ratio of the Trade (in US$) in Middle East & North Africa (developing only) in 2002 to that in 2004?
Your answer should be very brief. 0.68. What is the ratio of the Trade (in US$) of Latvia in 2002 to that in 2004?
Provide a succinct answer. 0.57. What is the ratio of the Trade (in US$) in Macedonia in 2002 to that in 2004?
Your response must be concise. 0.64. What is the ratio of the Trade (in US$) in Swaziland in 2002 to that in 2004?
Make the answer very short. 0.58. What is the ratio of the Trade (in US$) in Middle East & North Africa (developing only) in 2002 to that in 2005?
Provide a short and direct response. 0.58. What is the ratio of the Trade (in US$) of Latvia in 2002 to that in 2005?
Your answer should be very brief. 0.46. What is the ratio of the Trade (in US$) in Macedonia in 2002 to that in 2005?
Offer a terse response. 0.57. What is the ratio of the Trade (in US$) in Swaziland in 2002 to that in 2005?
Provide a succinct answer. 0.52. What is the ratio of the Trade (in US$) in Middle East & North Africa (developing only) in 2002 to that in 2006?
Offer a very short reply. 0.54. What is the ratio of the Trade (in US$) of Latvia in 2002 to that in 2006?
Your answer should be compact. 0.34. What is the ratio of the Trade (in US$) of Macedonia in 2002 to that in 2006?
Offer a very short reply. 0.48. What is the ratio of the Trade (in US$) in Swaziland in 2002 to that in 2006?
Offer a very short reply. 0.53. What is the ratio of the Trade (in US$) of Middle East & North Africa (developing only) in 2002 to that in 2007?
Make the answer very short. 0.44. What is the ratio of the Trade (in US$) of Latvia in 2002 to that in 2007?
Provide a short and direct response. 0.25. What is the ratio of the Trade (in US$) in Macedonia in 2002 to that in 2007?
Make the answer very short. 0.35. What is the ratio of the Trade (in US$) of Swaziland in 2002 to that in 2007?
Give a very brief answer. 0.53. What is the ratio of the Trade (in US$) in Middle East & North Africa (developing only) in 2003 to that in 2004?
Give a very brief answer. 0.79. What is the ratio of the Trade (in US$) of Latvia in 2003 to that in 2004?
Your response must be concise. 0.73. What is the ratio of the Trade (in US$) of Macedonia in 2003 to that in 2004?
Your response must be concise. 0.75. What is the ratio of the Trade (in US$) in Swaziland in 2003 to that in 2004?
Offer a very short reply. 0.89. What is the ratio of the Trade (in US$) in Middle East & North Africa (developing only) in 2003 to that in 2005?
Give a very brief answer. 0.67. What is the ratio of the Trade (in US$) of Latvia in 2003 to that in 2005?
Your answer should be compact. 0.59. What is the ratio of the Trade (in US$) in Macedonia in 2003 to that in 2005?
Give a very brief answer. 0.67. What is the ratio of the Trade (in US$) of Swaziland in 2003 to that in 2005?
Ensure brevity in your answer.  0.8. What is the ratio of the Trade (in US$) of Middle East & North Africa (developing only) in 2003 to that in 2006?
Your answer should be compact. 0.62. What is the ratio of the Trade (in US$) in Latvia in 2003 to that in 2006?
Your answer should be compact. 0.44. What is the ratio of the Trade (in US$) of Macedonia in 2003 to that in 2006?
Give a very brief answer. 0.57. What is the ratio of the Trade (in US$) in Swaziland in 2003 to that in 2006?
Keep it short and to the point. 0.81. What is the ratio of the Trade (in US$) of Middle East & North Africa (developing only) in 2003 to that in 2007?
Your response must be concise. 0.51. What is the ratio of the Trade (in US$) in Latvia in 2003 to that in 2007?
Your answer should be very brief. 0.32. What is the ratio of the Trade (in US$) of Macedonia in 2003 to that in 2007?
Provide a succinct answer. 0.42. What is the ratio of the Trade (in US$) of Swaziland in 2003 to that in 2007?
Keep it short and to the point. 0.8. What is the ratio of the Trade (in US$) in Middle East & North Africa (developing only) in 2004 to that in 2005?
Your answer should be very brief. 0.86. What is the ratio of the Trade (in US$) in Latvia in 2004 to that in 2005?
Provide a succinct answer. 0.8. What is the ratio of the Trade (in US$) in Macedonia in 2004 to that in 2005?
Your response must be concise. 0.89. What is the ratio of the Trade (in US$) in Swaziland in 2004 to that in 2005?
Provide a succinct answer. 0.9. What is the ratio of the Trade (in US$) of Middle East & North Africa (developing only) in 2004 to that in 2006?
Ensure brevity in your answer.  0.79. What is the ratio of the Trade (in US$) in Latvia in 2004 to that in 2006?
Your answer should be very brief. 0.6. What is the ratio of the Trade (in US$) in Macedonia in 2004 to that in 2006?
Offer a very short reply. 0.76. What is the ratio of the Trade (in US$) in Middle East & North Africa (developing only) in 2004 to that in 2007?
Offer a terse response. 0.64. What is the ratio of the Trade (in US$) in Latvia in 2004 to that in 2007?
Provide a succinct answer. 0.44. What is the ratio of the Trade (in US$) of Macedonia in 2004 to that in 2007?
Your answer should be compact. 0.55. What is the ratio of the Trade (in US$) of Swaziland in 2004 to that in 2007?
Make the answer very short. 0.9. What is the ratio of the Trade (in US$) of Middle East & North Africa (developing only) in 2005 to that in 2006?
Your answer should be compact. 0.92. What is the ratio of the Trade (in US$) in Latvia in 2005 to that in 2006?
Provide a succinct answer. 0.75. What is the ratio of the Trade (in US$) of Macedonia in 2005 to that in 2006?
Keep it short and to the point. 0.85. What is the ratio of the Trade (in US$) in Swaziland in 2005 to that in 2006?
Keep it short and to the point. 1.01. What is the ratio of the Trade (in US$) of Middle East & North Africa (developing only) in 2005 to that in 2007?
Ensure brevity in your answer.  0.75. What is the ratio of the Trade (in US$) of Latvia in 2005 to that in 2007?
Your answer should be compact. 0.55. What is the ratio of the Trade (in US$) in Macedonia in 2005 to that in 2007?
Provide a short and direct response. 0.62. What is the ratio of the Trade (in US$) in Swaziland in 2005 to that in 2007?
Ensure brevity in your answer.  1. What is the ratio of the Trade (in US$) of Middle East & North Africa (developing only) in 2006 to that in 2007?
Ensure brevity in your answer.  0.81. What is the ratio of the Trade (in US$) of Latvia in 2006 to that in 2007?
Give a very brief answer. 0.73. What is the ratio of the Trade (in US$) of Macedonia in 2006 to that in 2007?
Ensure brevity in your answer.  0.73. What is the ratio of the Trade (in US$) in Swaziland in 2006 to that in 2007?
Offer a very short reply. 0.99. What is the difference between the highest and the second highest Trade (in US$) of Middle East & North Africa (developing only)?
Your response must be concise. 5.84e+1. What is the difference between the highest and the second highest Trade (in US$) of Latvia?
Offer a terse response. 4.75e+09. What is the difference between the highest and the second highest Trade (in US$) in Macedonia?
Ensure brevity in your answer.  1.41e+09. What is the difference between the highest and the second highest Trade (in US$) of Swaziland?
Offer a terse response. 6.24e+06. What is the difference between the highest and the lowest Trade (in US$) of Middle East & North Africa (developing only)?
Offer a very short reply. 1.93e+11. What is the difference between the highest and the lowest Trade (in US$) in Latvia?
Ensure brevity in your answer.  1.42e+1. What is the difference between the highest and the lowest Trade (in US$) of Macedonia?
Keep it short and to the point. 3.60e+09. What is the difference between the highest and the lowest Trade (in US$) of Swaziland?
Give a very brief answer. 1.12e+09. 